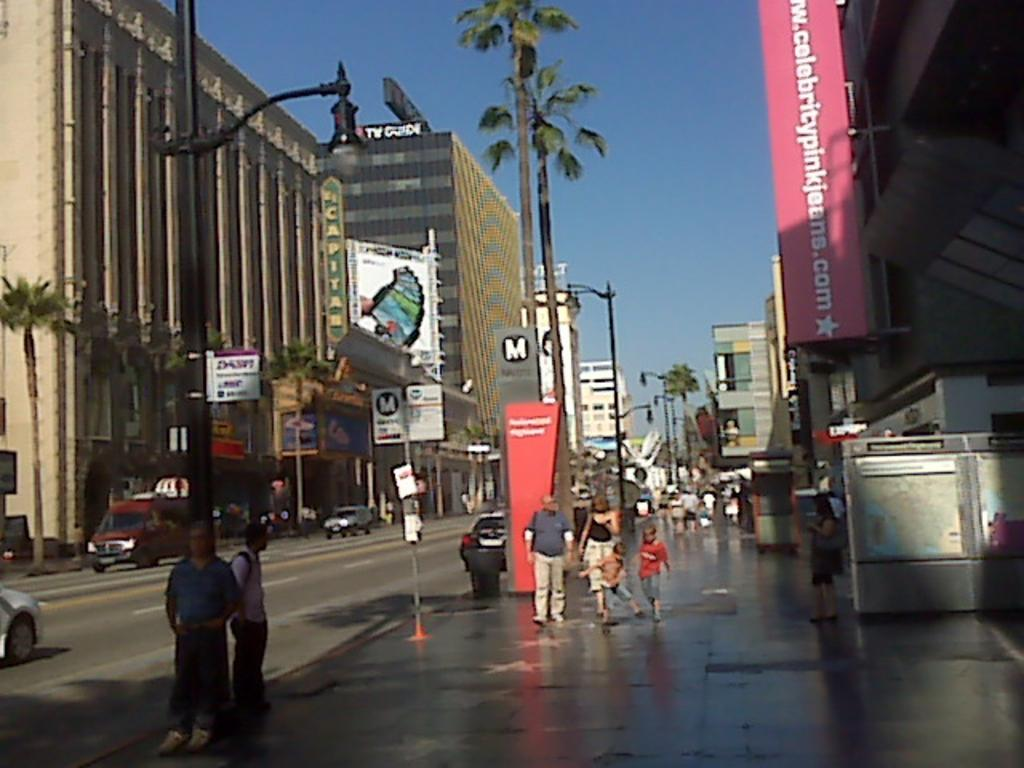<image>
Write a terse but informative summary of the picture. Palm trees and a banner with Celebritypinkjeans.com are seen near many pedestrians. 